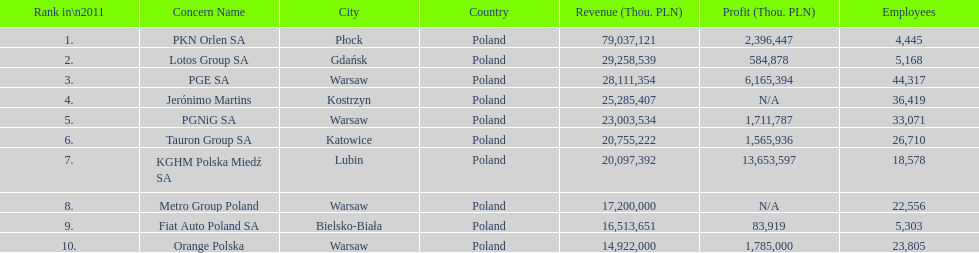What company has the top number of employees? PGE SA. 